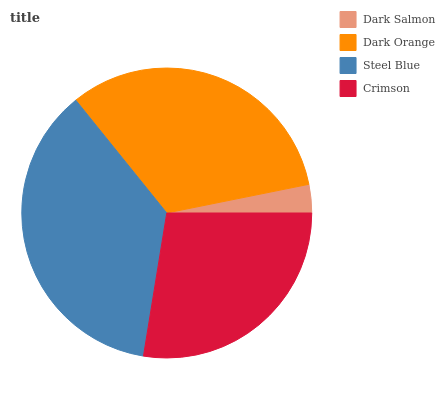Is Dark Salmon the minimum?
Answer yes or no. Yes. Is Steel Blue the maximum?
Answer yes or no. Yes. Is Dark Orange the minimum?
Answer yes or no. No. Is Dark Orange the maximum?
Answer yes or no. No. Is Dark Orange greater than Dark Salmon?
Answer yes or no. Yes. Is Dark Salmon less than Dark Orange?
Answer yes or no. Yes. Is Dark Salmon greater than Dark Orange?
Answer yes or no. No. Is Dark Orange less than Dark Salmon?
Answer yes or no. No. Is Dark Orange the high median?
Answer yes or no. Yes. Is Crimson the low median?
Answer yes or no. Yes. Is Crimson the high median?
Answer yes or no. No. Is Dark Salmon the low median?
Answer yes or no. No. 